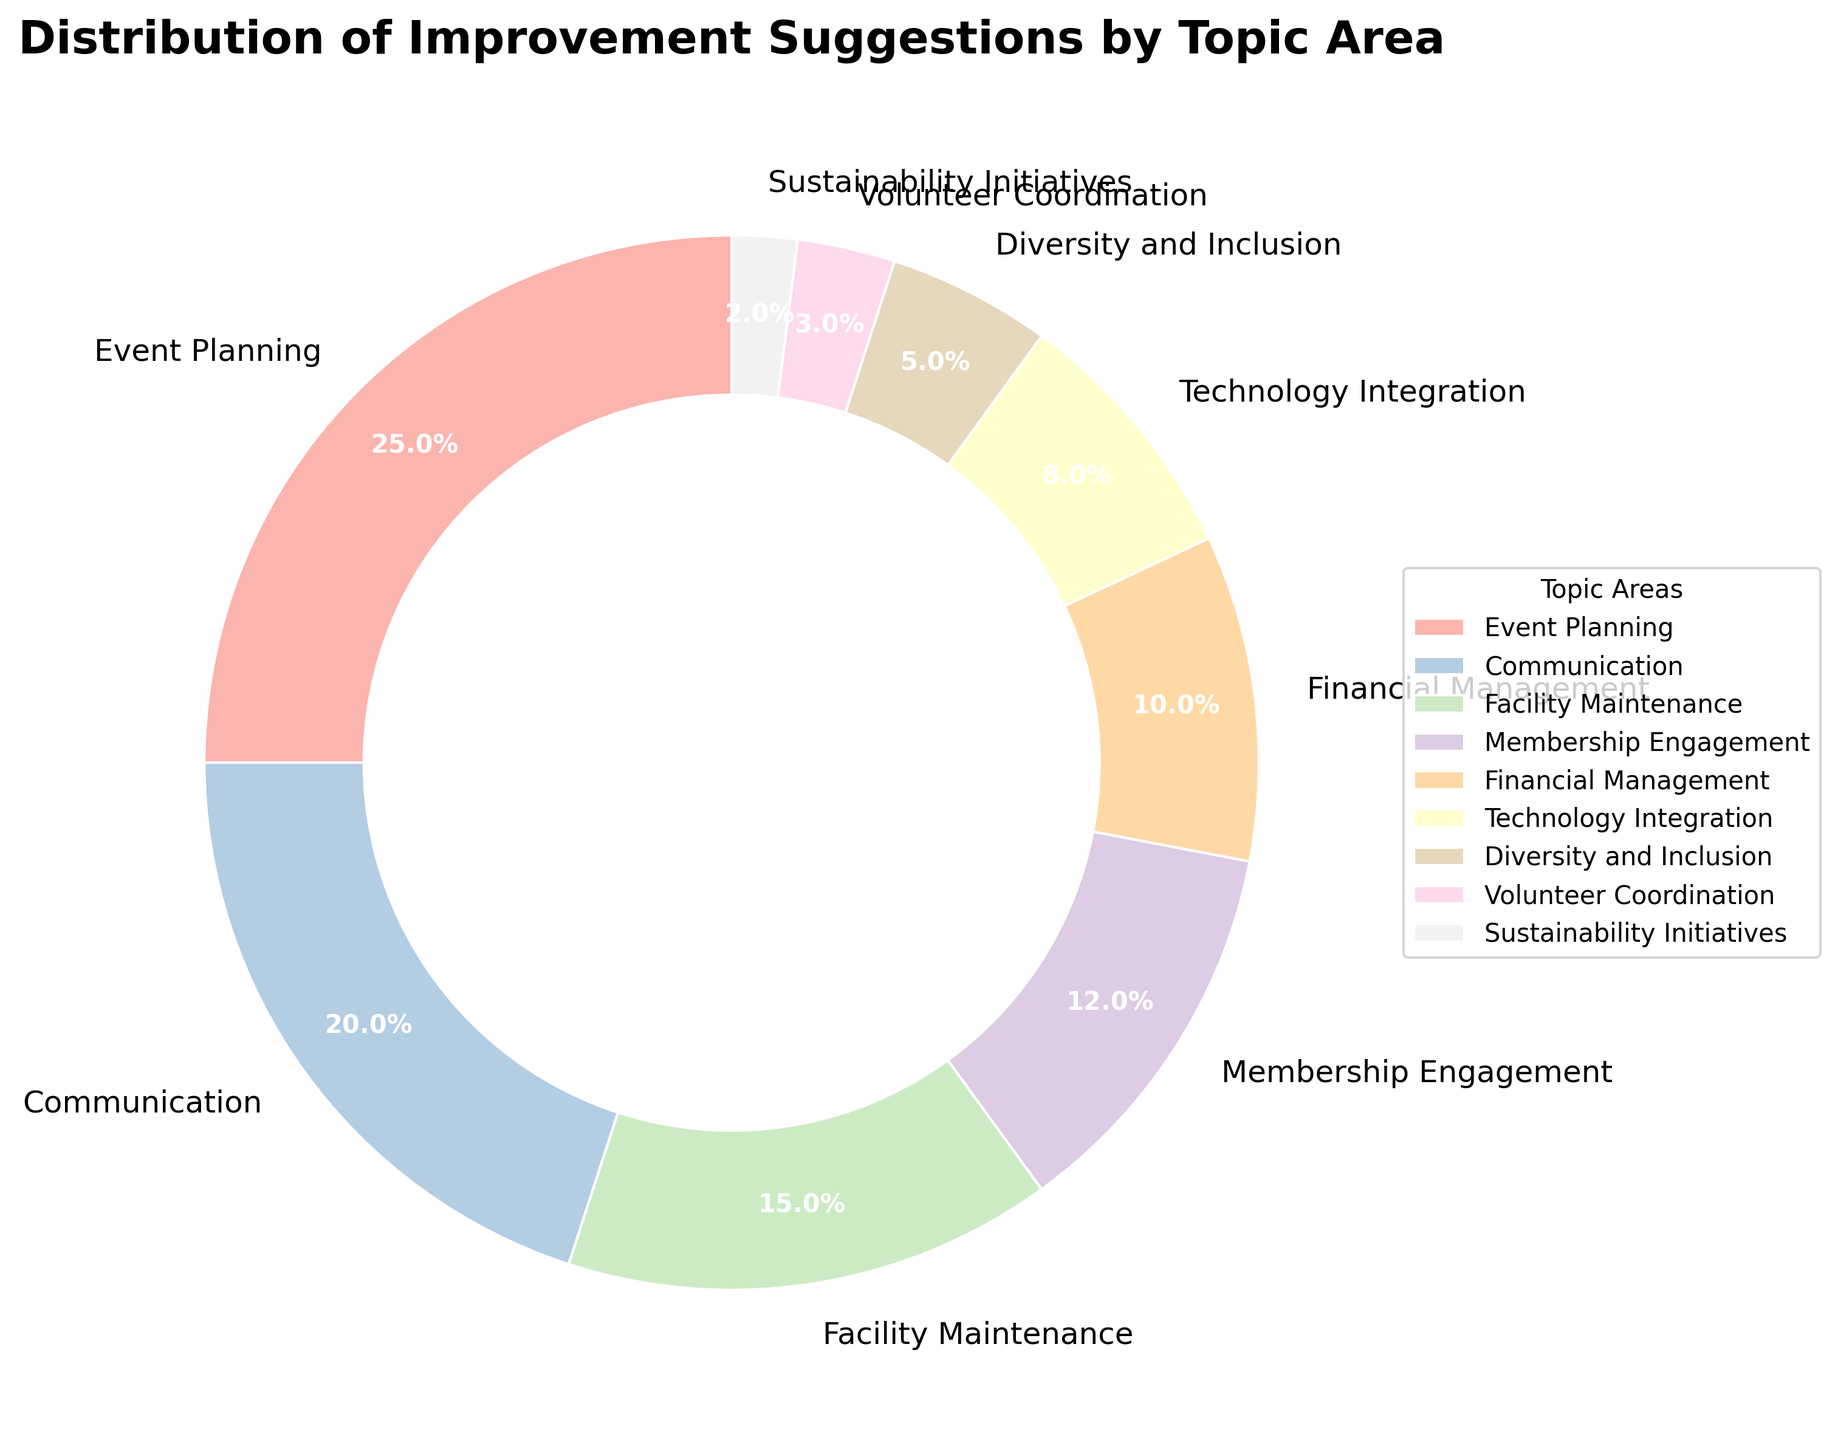What is the topic area with the highest percentage of improvement suggestions? Look at the segment with the largest size in the pie chart. The largest segment represents the "Event Planning" topic area with 25%.
Answer: Event Planning How much greater is the percentage of suggestions for Communication compared to Sustainability Initiatives? Subtract the percentage of "Sustainability Initiatives" from the percentage of "Communication". That is 20% - 2% = 18%.
Answer: 18% Which two topic areas combined give a total of 30% of improvement suggestions? Find two topic areas whose percentages sum up to 30%. "Technology Integration" (8%) and "Financial Management" (10%) together give 18%, while "Membership Engagement" (12%) and "Financial Management" (10%) together total 22%, amongst others. However, "Facility Maintenance" (15%) and "Membership Engagement" (12%) combined give an exact sum 27% and adding "Sustainability Initiatives" (3%) to this makes 30%.
Answer: Facility Maintenance and Sustainability Initiatives What is the percentage difference between Technology Integration and Volunteer Coordination? Subtract the percentage of "Volunteer Coordination" from "Technology Integration". That is 8% - 3% = 5%.
Answer: 5% If you combine the suggestions for Facility Maintenance and Financial Management, what would be their total percentage? Add the percentage of "Facility Maintenance" (15%) and "Financial Management" (10%) which equals 25%.
Answer: 25% Which segment has a color closest to the center of the color spectrum used? Look at segments in the plot having pastel colors where those in the middle of the color progression from light to dark would be mid-way in the spectrum. "Membership Engagement" often falls in that range depending on color mapping defined.
Answer: Membership Engagement Which topic area has the smallest number of suggestions, and what is its percentage? Find the smallest segment in the pie chart; it is "Sustainability Initiatives" with 2%.
Answer: Sustainability Initiatives, 2% Among the listed topics, which area has a slightly higher percentage of suggestions than Membership Engagement? Compare the percentage of "Membership Engagement" (12%) with slightly higher segments. The next highest is "Facility Maintenance" with 15%.
Answer: Facility Maintenance 